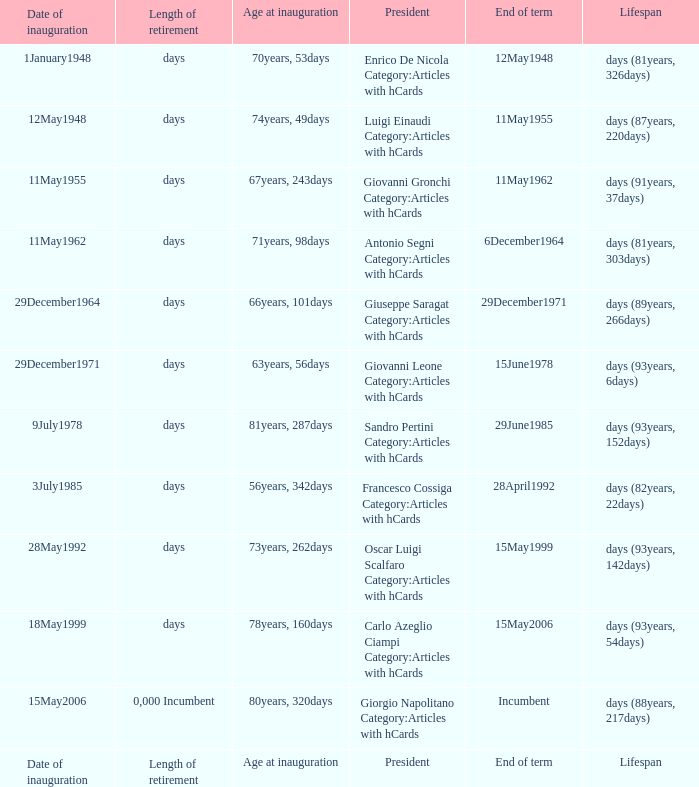What is the End of term of the President with an Age at inauguration of 78years, 160days? 15May2006. 